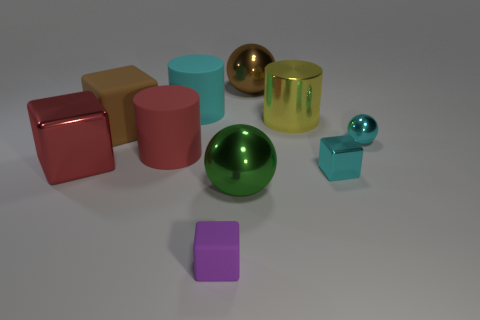Subtract all small rubber cubes. How many cubes are left? 3 Subtract all cyan cylinders. How many cylinders are left? 2 Subtract 3 spheres. How many spheres are left? 0 Subtract all balls. How many objects are left? 7 Add 2 red rubber cylinders. How many red rubber cylinders are left? 3 Add 2 yellow matte blocks. How many yellow matte blocks exist? 2 Subtract 1 brown blocks. How many objects are left? 9 Subtract all green cubes. Subtract all yellow spheres. How many cubes are left? 4 Subtract all large blue rubber blocks. Subtract all large things. How many objects are left? 3 